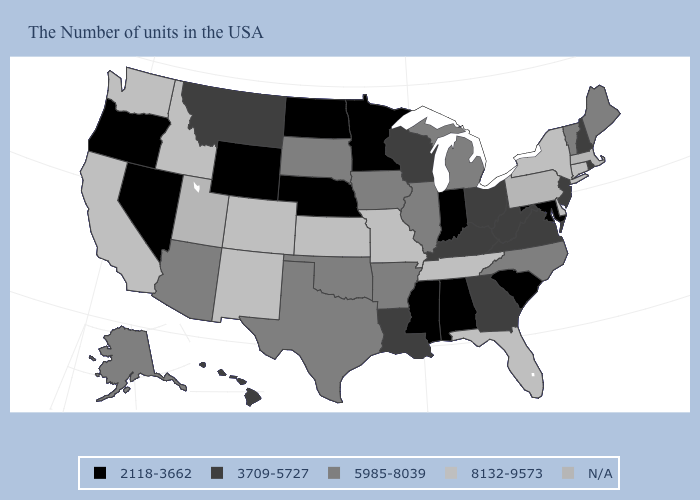What is the value of New Mexico?
Give a very brief answer. 8132-9573. How many symbols are there in the legend?
Answer briefly. 5. What is the value of Arkansas?
Write a very short answer. 5985-8039. What is the value of West Virginia?
Short answer required. 3709-5727. Name the states that have a value in the range 5985-8039?
Give a very brief answer. Maine, Vermont, North Carolina, Michigan, Illinois, Arkansas, Iowa, Oklahoma, Texas, South Dakota, Arizona, Alaska. What is the value of Arizona?
Concise answer only. 5985-8039. Which states hav the highest value in the South?
Write a very short answer. Delaware, Florida, Tennessee. What is the value of Massachusetts?
Quick response, please. N/A. Does Missouri have the highest value in the USA?
Keep it brief. Yes. What is the lowest value in the USA?
Keep it brief. 2118-3662. Name the states that have a value in the range 8132-9573?
Short answer required. Connecticut, New York, Delaware, Florida, Tennessee, Missouri, Kansas, Colorado, New Mexico, Idaho, California, Washington. Name the states that have a value in the range 8132-9573?
Keep it brief. Connecticut, New York, Delaware, Florida, Tennessee, Missouri, Kansas, Colorado, New Mexico, Idaho, California, Washington. What is the value of Oregon?
Short answer required. 2118-3662. Is the legend a continuous bar?
Quick response, please. No. 